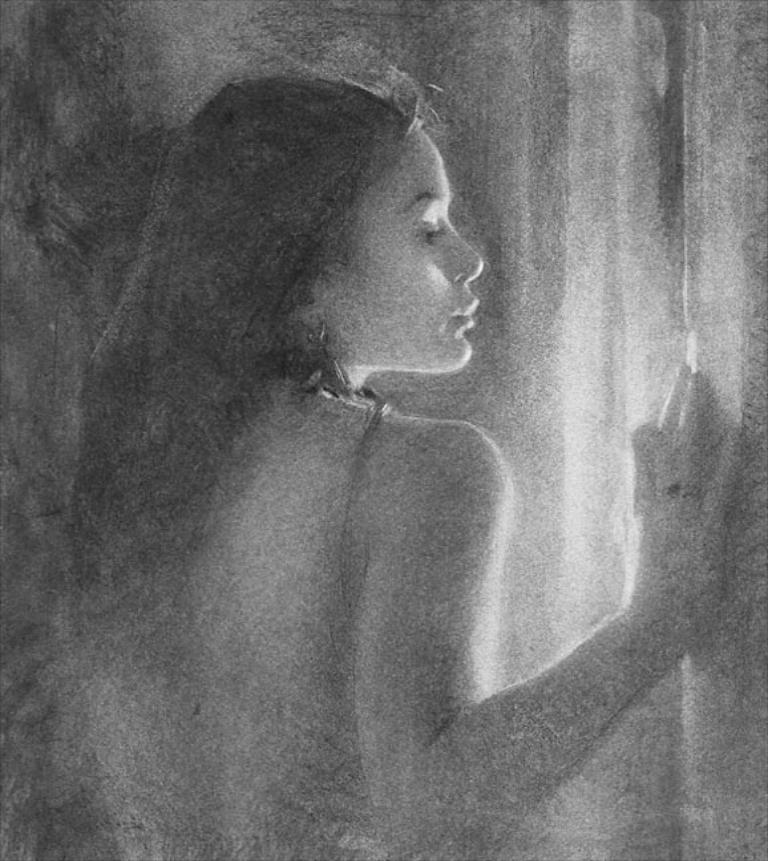What is the color scheme of the image? The image is black and white. Can you describe the main subject of the image? There is a woman in the image. What territory does the woman's aunt claim in the image? There is no mention of territory or the woman's aunt in the image. 